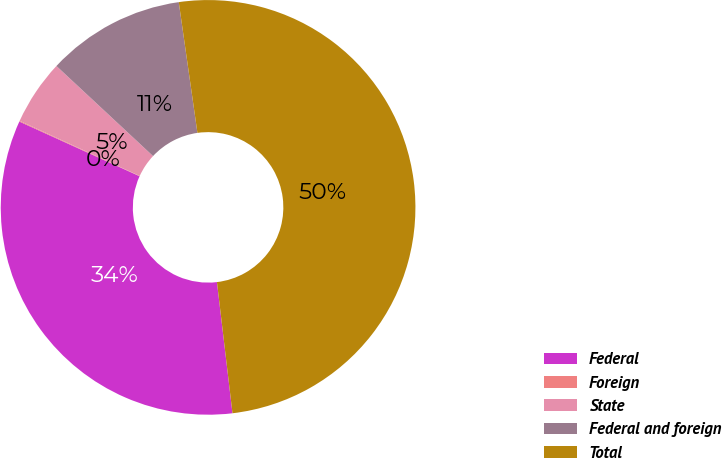Convert chart. <chart><loc_0><loc_0><loc_500><loc_500><pie_chart><fcel>Federal<fcel>Foreign<fcel>State<fcel>Federal and foreign<fcel>Total<nl><fcel>33.67%<fcel>0.06%<fcel>5.09%<fcel>10.8%<fcel>50.38%<nl></chart> 